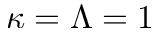<formula> <loc_0><loc_0><loc_500><loc_500>\kappa = \Lambda = 1</formula> 